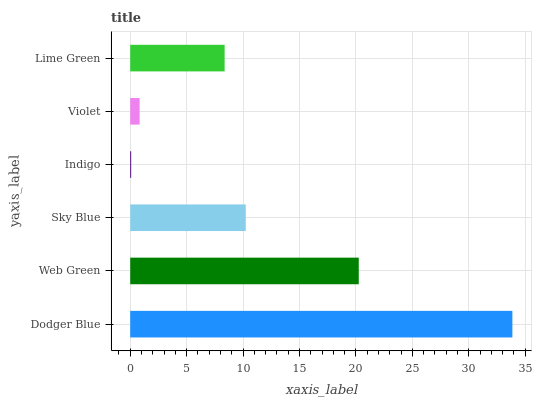Is Indigo the minimum?
Answer yes or no. Yes. Is Dodger Blue the maximum?
Answer yes or no. Yes. Is Web Green the minimum?
Answer yes or no. No. Is Web Green the maximum?
Answer yes or no. No. Is Dodger Blue greater than Web Green?
Answer yes or no. Yes. Is Web Green less than Dodger Blue?
Answer yes or no. Yes. Is Web Green greater than Dodger Blue?
Answer yes or no. No. Is Dodger Blue less than Web Green?
Answer yes or no. No. Is Sky Blue the high median?
Answer yes or no. Yes. Is Lime Green the low median?
Answer yes or no. Yes. Is Lime Green the high median?
Answer yes or no. No. Is Dodger Blue the low median?
Answer yes or no. No. 